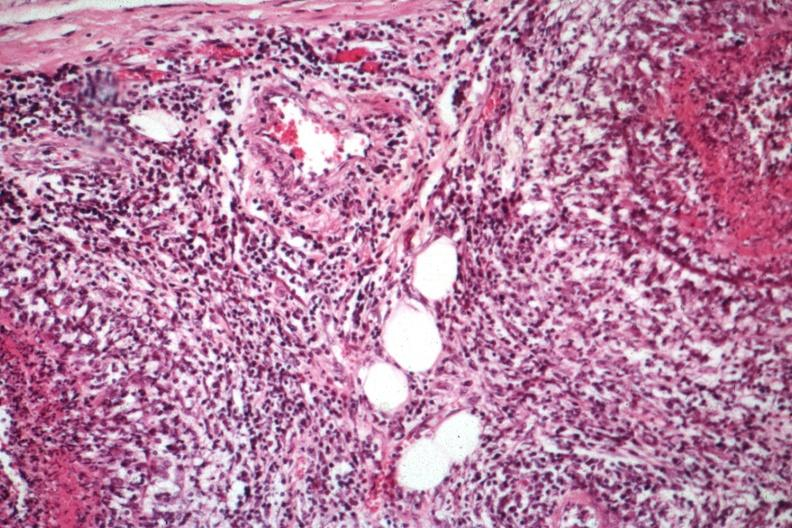what is present?
Answer the question using a single word or phrase. Rheumatoid arthritis with vasculitis 